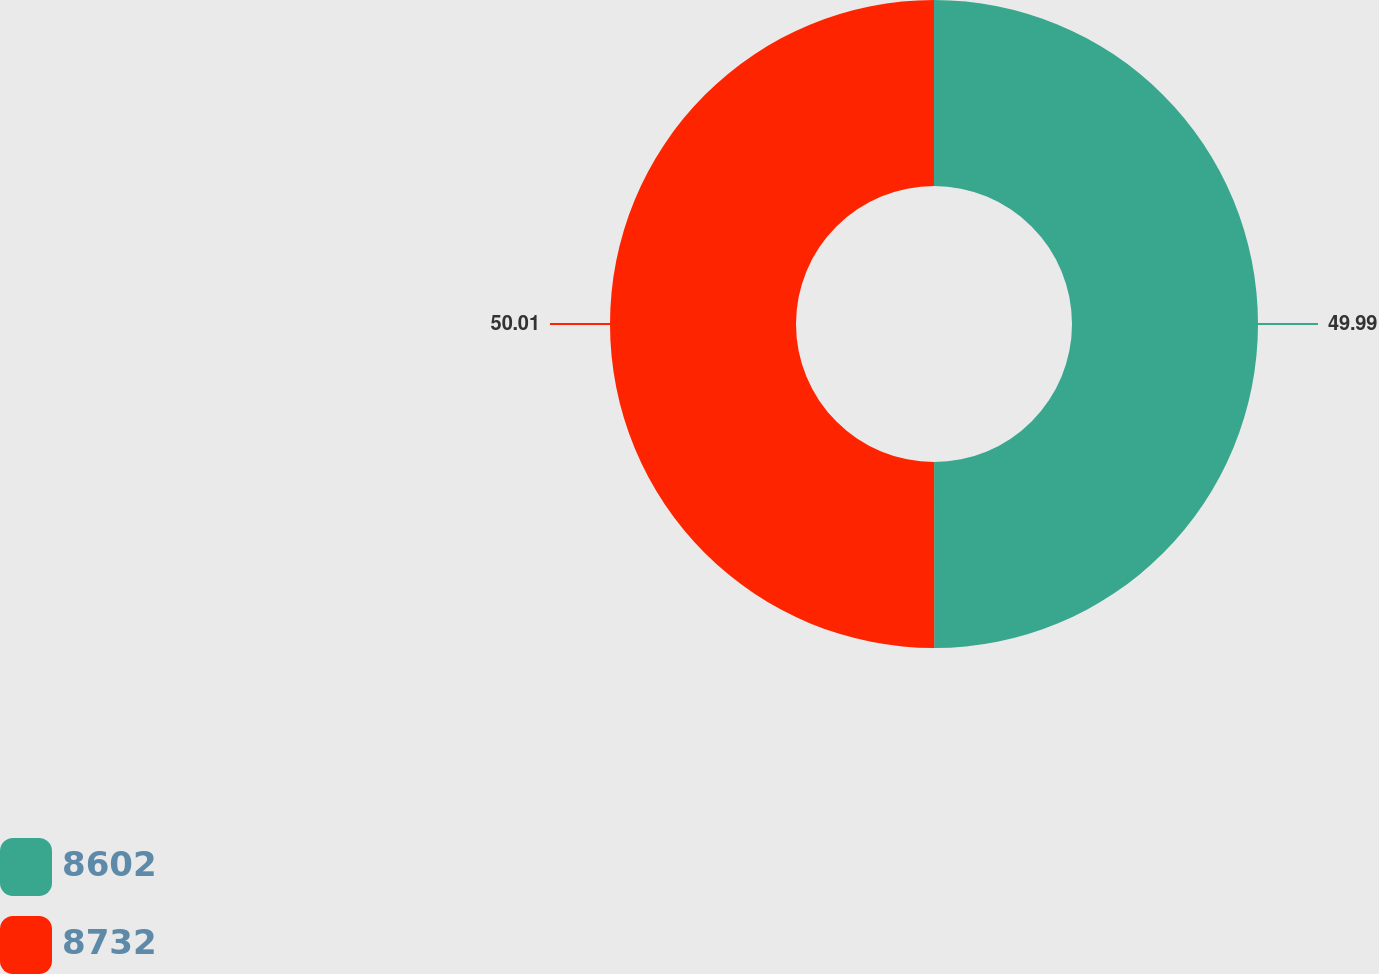Convert chart to OTSL. <chart><loc_0><loc_0><loc_500><loc_500><pie_chart><fcel>8602<fcel>8732<nl><fcel>49.99%<fcel>50.01%<nl></chart> 